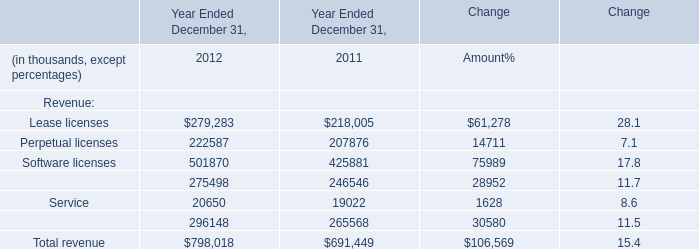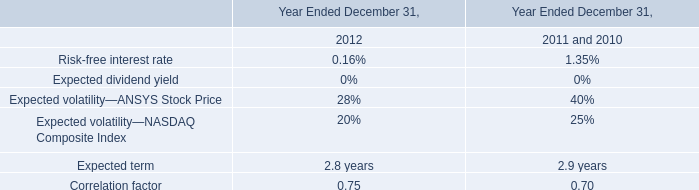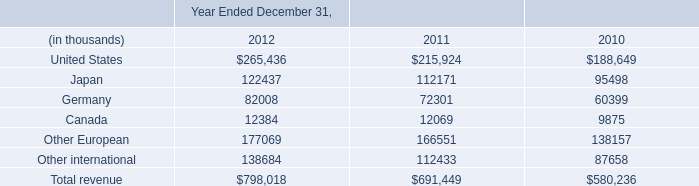What's the average of Other European of Year Ended December 31, 2011, and Maintenance and service of Year Ended December 31, 2011 ? 
Computations: ((166551.0 + 265568.0) / 2)
Answer: 216059.5. 